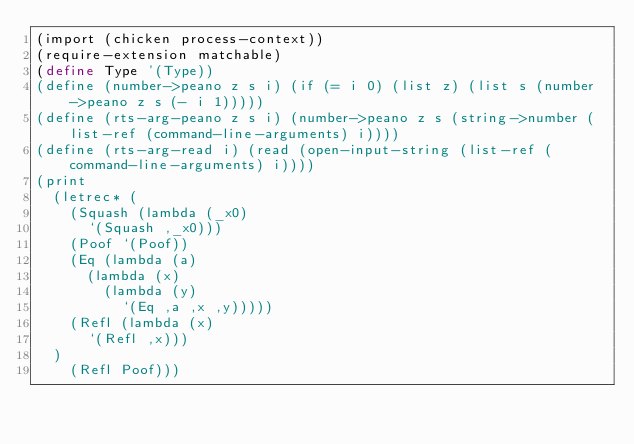Convert code to text. <code><loc_0><loc_0><loc_500><loc_500><_Scheme_>(import (chicken process-context))
(require-extension matchable)
(define Type '(Type))
(define (number->peano z s i) (if (= i 0) (list z) (list s (number->peano z s (- i 1)))))
(define (rts-arg-peano z s i) (number->peano z s (string->number (list-ref (command-line-arguments) i))))
(define (rts-arg-read i) (read (open-input-string (list-ref (command-line-arguments) i))))
(print
  (letrec* (
    (Squash (lambda (_x0)
      `(Squash ,_x0)))
    (Poof `(Poof))
    (Eq (lambda (a)
      (lambda (x)
        (lambda (y)
          `(Eq ,a ,x ,y)))))
    (Refl (lambda (x)
      `(Refl ,x)))
  )
    (Refl Poof)))
</code> 